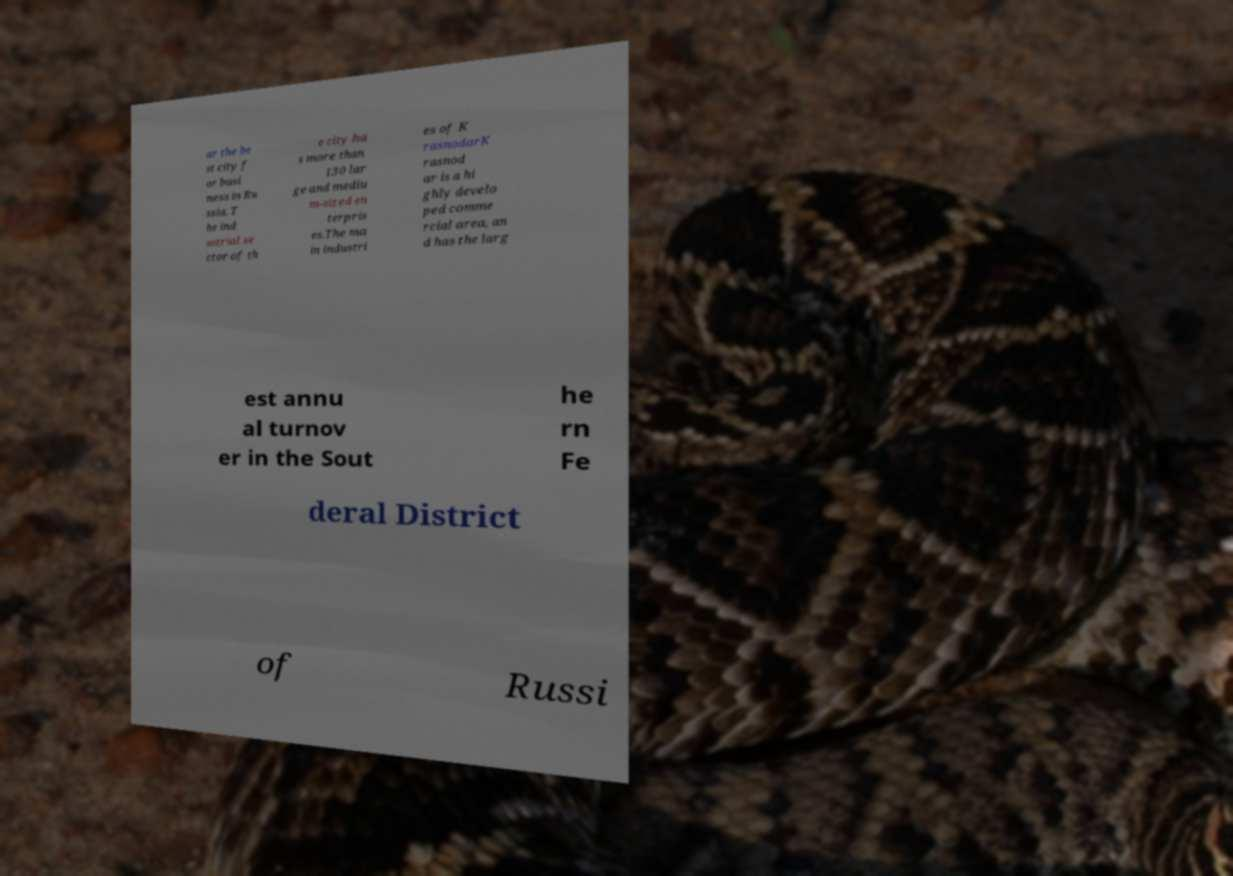There's text embedded in this image that I need extracted. Can you transcribe it verbatim? ar the be st city f or busi ness in Ru ssia. T he ind ustrial se ctor of th e city ha s more than 130 lar ge and mediu m-sized en terpris es.The ma in industri es of K rasnodarK rasnod ar is a hi ghly develo ped comme rcial area, an d has the larg est annu al turnov er in the Sout he rn Fe deral District of Russi 